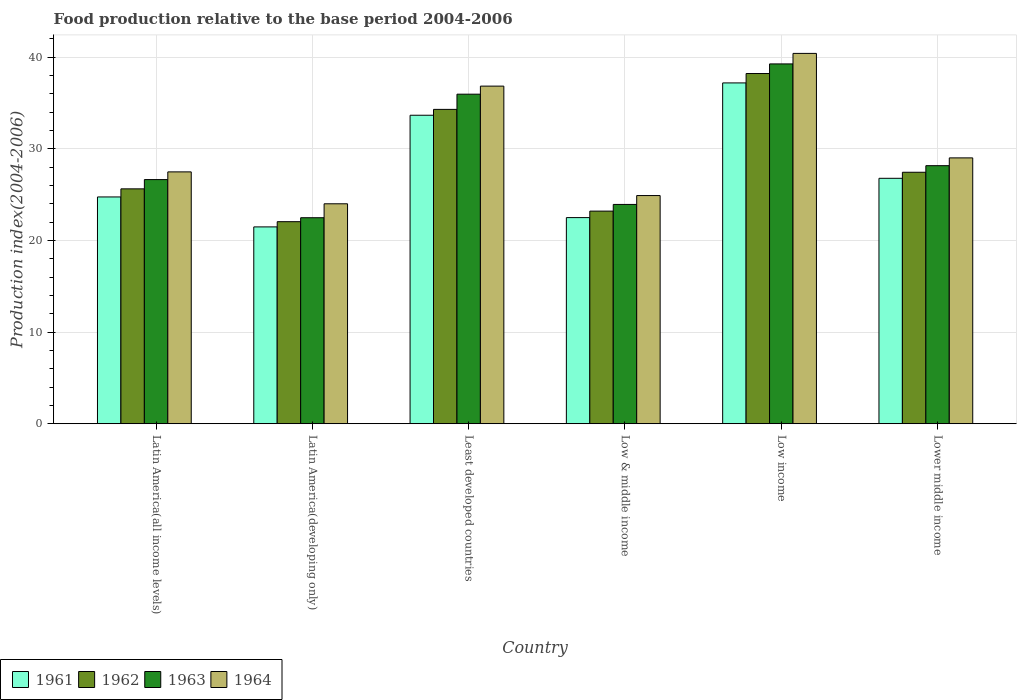How many different coloured bars are there?
Make the answer very short. 4. Are the number of bars per tick equal to the number of legend labels?
Provide a short and direct response. Yes. What is the label of the 6th group of bars from the left?
Give a very brief answer. Lower middle income. In how many cases, is the number of bars for a given country not equal to the number of legend labels?
Your answer should be very brief. 0. What is the food production index in 1963 in Least developed countries?
Your response must be concise. 35.95. Across all countries, what is the maximum food production index in 1964?
Your response must be concise. 40.39. Across all countries, what is the minimum food production index in 1963?
Provide a succinct answer. 22.47. In which country was the food production index in 1964 maximum?
Ensure brevity in your answer.  Low income. In which country was the food production index in 1962 minimum?
Ensure brevity in your answer.  Latin America(developing only). What is the total food production index in 1961 in the graph?
Provide a succinct answer. 166.28. What is the difference between the food production index in 1964 in Latin America(all income levels) and that in Low income?
Your response must be concise. -12.92. What is the difference between the food production index in 1961 in Lower middle income and the food production index in 1963 in Least developed countries?
Offer a terse response. -9.18. What is the average food production index in 1964 per country?
Offer a terse response. 30.43. What is the difference between the food production index of/in 1964 and food production index of/in 1962 in Lower middle income?
Give a very brief answer. 1.57. In how many countries, is the food production index in 1964 greater than 38?
Provide a short and direct response. 1. What is the ratio of the food production index in 1962 in Latin America(developing only) to that in Least developed countries?
Offer a very short reply. 0.64. Is the food production index in 1962 in Least developed countries less than that in Low income?
Provide a short and direct response. Yes. What is the difference between the highest and the second highest food production index in 1964?
Give a very brief answer. 3.57. What is the difference between the highest and the lowest food production index in 1963?
Your answer should be very brief. 16.78. In how many countries, is the food production index in 1963 greater than the average food production index in 1963 taken over all countries?
Make the answer very short. 2. Is it the case that in every country, the sum of the food production index in 1962 and food production index in 1964 is greater than the food production index in 1963?
Offer a very short reply. Yes. Are all the bars in the graph horizontal?
Provide a succinct answer. No. How many countries are there in the graph?
Keep it short and to the point. 6. How many legend labels are there?
Ensure brevity in your answer.  4. How are the legend labels stacked?
Your response must be concise. Horizontal. What is the title of the graph?
Ensure brevity in your answer.  Food production relative to the base period 2004-2006. What is the label or title of the Y-axis?
Provide a short and direct response. Production index(2004-2006). What is the Production index(2004-2006) of 1961 in Latin America(all income levels)?
Your answer should be compact. 24.74. What is the Production index(2004-2006) in 1962 in Latin America(all income levels)?
Offer a very short reply. 25.62. What is the Production index(2004-2006) in 1963 in Latin America(all income levels)?
Ensure brevity in your answer.  26.63. What is the Production index(2004-2006) in 1964 in Latin America(all income levels)?
Your answer should be compact. 27.47. What is the Production index(2004-2006) in 1961 in Latin America(developing only)?
Your answer should be very brief. 21.47. What is the Production index(2004-2006) in 1962 in Latin America(developing only)?
Your response must be concise. 22.04. What is the Production index(2004-2006) of 1963 in Latin America(developing only)?
Your answer should be compact. 22.47. What is the Production index(2004-2006) of 1964 in Latin America(developing only)?
Ensure brevity in your answer.  23.99. What is the Production index(2004-2006) in 1961 in Least developed countries?
Your response must be concise. 33.65. What is the Production index(2004-2006) of 1962 in Least developed countries?
Keep it short and to the point. 34.29. What is the Production index(2004-2006) in 1963 in Least developed countries?
Make the answer very short. 35.95. What is the Production index(2004-2006) of 1964 in Least developed countries?
Give a very brief answer. 36.83. What is the Production index(2004-2006) of 1961 in Low & middle income?
Keep it short and to the point. 22.48. What is the Production index(2004-2006) of 1962 in Low & middle income?
Ensure brevity in your answer.  23.19. What is the Production index(2004-2006) in 1963 in Low & middle income?
Provide a succinct answer. 23.92. What is the Production index(2004-2006) of 1964 in Low & middle income?
Give a very brief answer. 24.89. What is the Production index(2004-2006) in 1961 in Low income?
Ensure brevity in your answer.  37.17. What is the Production index(2004-2006) of 1962 in Low income?
Your answer should be very brief. 38.2. What is the Production index(2004-2006) in 1963 in Low income?
Your answer should be very brief. 39.25. What is the Production index(2004-2006) in 1964 in Low income?
Your answer should be very brief. 40.39. What is the Production index(2004-2006) in 1961 in Lower middle income?
Keep it short and to the point. 26.77. What is the Production index(2004-2006) in 1962 in Lower middle income?
Offer a very short reply. 27.43. What is the Production index(2004-2006) of 1963 in Lower middle income?
Ensure brevity in your answer.  28.15. What is the Production index(2004-2006) of 1964 in Lower middle income?
Your answer should be very brief. 29. Across all countries, what is the maximum Production index(2004-2006) of 1961?
Your answer should be compact. 37.17. Across all countries, what is the maximum Production index(2004-2006) in 1962?
Make the answer very short. 38.2. Across all countries, what is the maximum Production index(2004-2006) in 1963?
Offer a very short reply. 39.25. Across all countries, what is the maximum Production index(2004-2006) in 1964?
Keep it short and to the point. 40.39. Across all countries, what is the minimum Production index(2004-2006) of 1961?
Provide a short and direct response. 21.47. Across all countries, what is the minimum Production index(2004-2006) of 1962?
Keep it short and to the point. 22.04. Across all countries, what is the minimum Production index(2004-2006) in 1963?
Provide a short and direct response. 22.47. Across all countries, what is the minimum Production index(2004-2006) of 1964?
Give a very brief answer. 23.99. What is the total Production index(2004-2006) in 1961 in the graph?
Offer a terse response. 166.28. What is the total Production index(2004-2006) in 1962 in the graph?
Keep it short and to the point. 170.77. What is the total Production index(2004-2006) of 1963 in the graph?
Your answer should be compact. 176.36. What is the total Production index(2004-2006) of 1964 in the graph?
Offer a very short reply. 182.57. What is the difference between the Production index(2004-2006) in 1961 in Latin America(all income levels) and that in Latin America(developing only)?
Give a very brief answer. 3.27. What is the difference between the Production index(2004-2006) in 1962 in Latin America(all income levels) and that in Latin America(developing only)?
Provide a short and direct response. 3.58. What is the difference between the Production index(2004-2006) of 1963 in Latin America(all income levels) and that in Latin America(developing only)?
Keep it short and to the point. 4.16. What is the difference between the Production index(2004-2006) in 1964 in Latin America(all income levels) and that in Latin America(developing only)?
Your response must be concise. 3.48. What is the difference between the Production index(2004-2006) in 1961 in Latin America(all income levels) and that in Least developed countries?
Provide a succinct answer. -8.91. What is the difference between the Production index(2004-2006) in 1962 in Latin America(all income levels) and that in Least developed countries?
Provide a short and direct response. -8.67. What is the difference between the Production index(2004-2006) of 1963 in Latin America(all income levels) and that in Least developed countries?
Ensure brevity in your answer.  -9.32. What is the difference between the Production index(2004-2006) in 1964 in Latin America(all income levels) and that in Least developed countries?
Keep it short and to the point. -9.35. What is the difference between the Production index(2004-2006) of 1961 in Latin America(all income levels) and that in Low & middle income?
Give a very brief answer. 2.25. What is the difference between the Production index(2004-2006) of 1962 in Latin America(all income levels) and that in Low & middle income?
Provide a succinct answer. 2.43. What is the difference between the Production index(2004-2006) in 1963 in Latin America(all income levels) and that in Low & middle income?
Offer a terse response. 2.71. What is the difference between the Production index(2004-2006) in 1964 in Latin America(all income levels) and that in Low & middle income?
Give a very brief answer. 2.58. What is the difference between the Production index(2004-2006) in 1961 in Latin America(all income levels) and that in Low income?
Offer a terse response. -12.44. What is the difference between the Production index(2004-2006) of 1962 in Latin America(all income levels) and that in Low income?
Make the answer very short. -12.58. What is the difference between the Production index(2004-2006) of 1963 in Latin America(all income levels) and that in Low income?
Offer a terse response. -12.62. What is the difference between the Production index(2004-2006) of 1964 in Latin America(all income levels) and that in Low income?
Your answer should be compact. -12.92. What is the difference between the Production index(2004-2006) in 1961 in Latin America(all income levels) and that in Lower middle income?
Your response must be concise. -2.03. What is the difference between the Production index(2004-2006) of 1962 in Latin America(all income levels) and that in Lower middle income?
Offer a very short reply. -1.81. What is the difference between the Production index(2004-2006) of 1963 in Latin America(all income levels) and that in Lower middle income?
Keep it short and to the point. -1.52. What is the difference between the Production index(2004-2006) in 1964 in Latin America(all income levels) and that in Lower middle income?
Make the answer very short. -1.53. What is the difference between the Production index(2004-2006) of 1961 in Latin America(developing only) and that in Least developed countries?
Provide a succinct answer. -12.18. What is the difference between the Production index(2004-2006) in 1962 in Latin America(developing only) and that in Least developed countries?
Your answer should be compact. -12.25. What is the difference between the Production index(2004-2006) of 1963 in Latin America(developing only) and that in Least developed countries?
Ensure brevity in your answer.  -13.47. What is the difference between the Production index(2004-2006) in 1964 in Latin America(developing only) and that in Least developed countries?
Provide a succinct answer. -12.83. What is the difference between the Production index(2004-2006) of 1961 in Latin America(developing only) and that in Low & middle income?
Offer a very short reply. -1.01. What is the difference between the Production index(2004-2006) in 1962 in Latin America(developing only) and that in Low & middle income?
Your response must be concise. -1.15. What is the difference between the Production index(2004-2006) of 1963 in Latin America(developing only) and that in Low & middle income?
Your answer should be very brief. -1.45. What is the difference between the Production index(2004-2006) of 1964 in Latin America(developing only) and that in Low & middle income?
Keep it short and to the point. -0.9. What is the difference between the Production index(2004-2006) in 1961 in Latin America(developing only) and that in Low income?
Provide a succinct answer. -15.71. What is the difference between the Production index(2004-2006) of 1962 in Latin America(developing only) and that in Low income?
Make the answer very short. -16.16. What is the difference between the Production index(2004-2006) of 1963 in Latin America(developing only) and that in Low income?
Your answer should be very brief. -16.78. What is the difference between the Production index(2004-2006) in 1964 in Latin America(developing only) and that in Low income?
Your answer should be compact. -16.4. What is the difference between the Production index(2004-2006) of 1961 in Latin America(developing only) and that in Lower middle income?
Your answer should be very brief. -5.3. What is the difference between the Production index(2004-2006) in 1962 in Latin America(developing only) and that in Lower middle income?
Your answer should be very brief. -5.39. What is the difference between the Production index(2004-2006) in 1963 in Latin America(developing only) and that in Lower middle income?
Ensure brevity in your answer.  -5.68. What is the difference between the Production index(2004-2006) of 1964 in Latin America(developing only) and that in Lower middle income?
Provide a short and direct response. -5.01. What is the difference between the Production index(2004-2006) in 1961 in Least developed countries and that in Low & middle income?
Ensure brevity in your answer.  11.17. What is the difference between the Production index(2004-2006) in 1962 in Least developed countries and that in Low & middle income?
Ensure brevity in your answer.  11.1. What is the difference between the Production index(2004-2006) in 1963 in Least developed countries and that in Low & middle income?
Ensure brevity in your answer.  12.02. What is the difference between the Production index(2004-2006) of 1964 in Least developed countries and that in Low & middle income?
Offer a terse response. 11.94. What is the difference between the Production index(2004-2006) in 1961 in Least developed countries and that in Low income?
Make the answer very short. -3.53. What is the difference between the Production index(2004-2006) in 1962 in Least developed countries and that in Low income?
Ensure brevity in your answer.  -3.91. What is the difference between the Production index(2004-2006) of 1963 in Least developed countries and that in Low income?
Your answer should be very brief. -3.3. What is the difference between the Production index(2004-2006) of 1964 in Least developed countries and that in Low income?
Give a very brief answer. -3.57. What is the difference between the Production index(2004-2006) of 1961 in Least developed countries and that in Lower middle income?
Make the answer very short. 6.88. What is the difference between the Production index(2004-2006) in 1962 in Least developed countries and that in Lower middle income?
Make the answer very short. 6.86. What is the difference between the Production index(2004-2006) of 1963 in Least developed countries and that in Lower middle income?
Your response must be concise. 7.8. What is the difference between the Production index(2004-2006) of 1964 in Least developed countries and that in Lower middle income?
Provide a succinct answer. 7.83. What is the difference between the Production index(2004-2006) of 1961 in Low & middle income and that in Low income?
Your answer should be very brief. -14.69. What is the difference between the Production index(2004-2006) in 1962 in Low & middle income and that in Low income?
Keep it short and to the point. -15.01. What is the difference between the Production index(2004-2006) in 1963 in Low & middle income and that in Low income?
Your answer should be very brief. -15.33. What is the difference between the Production index(2004-2006) of 1964 in Low & middle income and that in Low income?
Offer a terse response. -15.51. What is the difference between the Production index(2004-2006) in 1961 in Low & middle income and that in Lower middle income?
Keep it short and to the point. -4.29. What is the difference between the Production index(2004-2006) in 1962 in Low & middle income and that in Lower middle income?
Give a very brief answer. -4.24. What is the difference between the Production index(2004-2006) of 1963 in Low & middle income and that in Lower middle income?
Your answer should be compact. -4.23. What is the difference between the Production index(2004-2006) in 1964 in Low & middle income and that in Lower middle income?
Give a very brief answer. -4.11. What is the difference between the Production index(2004-2006) in 1961 in Low income and that in Lower middle income?
Give a very brief answer. 10.4. What is the difference between the Production index(2004-2006) of 1962 in Low income and that in Lower middle income?
Keep it short and to the point. 10.77. What is the difference between the Production index(2004-2006) of 1963 in Low income and that in Lower middle income?
Offer a very short reply. 11.1. What is the difference between the Production index(2004-2006) in 1964 in Low income and that in Lower middle income?
Keep it short and to the point. 11.4. What is the difference between the Production index(2004-2006) of 1961 in Latin America(all income levels) and the Production index(2004-2006) of 1962 in Latin America(developing only)?
Ensure brevity in your answer.  2.7. What is the difference between the Production index(2004-2006) of 1961 in Latin America(all income levels) and the Production index(2004-2006) of 1963 in Latin America(developing only)?
Ensure brevity in your answer.  2.27. What is the difference between the Production index(2004-2006) in 1961 in Latin America(all income levels) and the Production index(2004-2006) in 1964 in Latin America(developing only)?
Give a very brief answer. 0.75. What is the difference between the Production index(2004-2006) of 1962 in Latin America(all income levels) and the Production index(2004-2006) of 1963 in Latin America(developing only)?
Ensure brevity in your answer.  3.15. What is the difference between the Production index(2004-2006) in 1962 in Latin America(all income levels) and the Production index(2004-2006) in 1964 in Latin America(developing only)?
Offer a very short reply. 1.63. What is the difference between the Production index(2004-2006) of 1963 in Latin America(all income levels) and the Production index(2004-2006) of 1964 in Latin America(developing only)?
Your answer should be very brief. 2.64. What is the difference between the Production index(2004-2006) of 1961 in Latin America(all income levels) and the Production index(2004-2006) of 1962 in Least developed countries?
Your answer should be very brief. -9.55. What is the difference between the Production index(2004-2006) in 1961 in Latin America(all income levels) and the Production index(2004-2006) in 1963 in Least developed countries?
Give a very brief answer. -11.21. What is the difference between the Production index(2004-2006) of 1961 in Latin America(all income levels) and the Production index(2004-2006) of 1964 in Least developed countries?
Provide a succinct answer. -12.09. What is the difference between the Production index(2004-2006) in 1962 in Latin America(all income levels) and the Production index(2004-2006) in 1963 in Least developed countries?
Ensure brevity in your answer.  -10.33. What is the difference between the Production index(2004-2006) in 1962 in Latin America(all income levels) and the Production index(2004-2006) in 1964 in Least developed countries?
Provide a succinct answer. -11.21. What is the difference between the Production index(2004-2006) in 1963 in Latin America(all income levels) and the Production index(2004-2006) in 1964 in Least developed countries?
Make the answer very short. -10.2. What is the difference between the Production index(2004-2006) of 1961 in Latin America(all income levels) and the Production index(2004-2006) of 1962 in Low & middle income?
Your answer should be very brief. 1.54. What is the difference between the Production index(2004-2006) in 1961 in Latin America(all income levels) and the Production index(2004-2006) in 1963 in Low & middle income?
Make the answer very short. 0.82. What is the difference between the Production index(2004-2006) of 1961 in Latin America(all income levels) and the Production index(2004-2006) of 1964 in Low & middle income?
Make the answer very short. -0.15. What is the difference between the Production index(2004-2006) of 1962 in Latin America(all income levels) and the Production index(2004-2006) of 1963 in Low & middle income?
Your answer should be very brief. 1.7. What is the difference between the Production index(2004-2006) in 1962 in Latin America(all income levels) and the Production index(2004-2006) in 1964 in Low & middle income?
Keep it short and to the point. 0.73. What is the difference between the Production index(2004-2006) in 1963 in Latin America(all income levels) and the Production index(2004-2006) in 1964 in Low & middle income?
Ensure brevity in your answer.  1.74. What is the difference between the Production index(2004-2006) in 1961 in Latin America(all income levels) and the Production index(2004-2006) in 1962 in Low income?
Make the answer very short. -13.46. What is the difference between the Production index(2004-2006) of 1961 in Latin America(all income levels) and the Production index(2004-2006) of 1963 in Low income?
Provide a succinct answer. -14.51. What is the difference between the Production index(2004-2006) of 1961 in Latin America(all income levels) and the Production index(2004-2006) of 1964 in Low income?
Your response must be concise. -15.66. What is the difference between the Production index(2004-2006) in 1962 in Latin America(all income levels) and the Production index(2004-2006) in 1963 in Low income?
Provide a short and direct response. -13.63. What is the difference between the Production index(2004-2006) in 1962 in Latin America(all income levels) and the Production index(2004-2006) in 1964 in Low income?
Make the answer very short. -14.77. What is the difference between the Production index(2004-2006) of 1963 in Latin America(all income levels) and the Production index(2004-2006) of 1964 in Low income?
Ensure brevity in your answer.  -13.76. What is the difference between the Production index(2004-2006) of 1961 in Latin America(all income levels) and the Production index(2004-2006) of 1962 in Lower middle income?
Your answer should be compact. -2.69. What is the difference between the Production index(2004-2006) of 1961 in Latin America(all income levels) and the Production index(2004-2006) of 1963 in Lower middle income?
Offer a very short reply. -3.41. What is the difference between the Production index(2004-2006) of 1961 in Latin America(all income levels) and the Production index(2004-2006) of 1964 in Lower middle income?
Offer a very short reply. -4.26. What is the difference between the Production index(2004-2006) in 1962 in Latin America(all income levels) and the Production index(2004-2006) in 1963 in Lower middle income?
Your answer should be very brief. -2.53. What is the difference between the Production index(2004-2006) in 1962 in Latin America(all income levels) and the Production index(2004-2006) in 1964 in Lower middle income?
Keep it short and to the point. -3.38. What is the difference between the Production index(2004-2006) of 1963 in Latin America(all income levels) and the Production index(2004-2006) of 1964 in Lower middle income?
Your answer should be very brief. -2.37. What is the difference between the Production index(2004-2006) of 1961 in Latin America(developing only) and the Production index(2004-2006) of 1962 in Least developed countries?
Your response must be concise. -12.82. What is the difference between the Production index(2004-2006) in 1961 in Latin America(developing only) and the Production index(2004-2006) in 1963 in Least developed countries?
Your answer should be very brief. -14.48. What is the difference between the Production index(2004-2006) of 1961 in Latin America(developing only) and the Production index(2004-2006) of 1964 in Least developed countries?
Offer a very short reply. -15.36. What is the difference between the Production index(2004-2006) in 1962 in Latin America(developing only) and the Production index(2004-2006) in 1963 in Least developed countries?
Provide a succinct answer. -13.91. What is the difference between the Production index(2004-2006) in 1962 in Latin America(developing only) and the Production index(2004-2006) in 1964 in Least developed countries?
Offer a very short reply. -14.79. What is the difference between the Production index(2004-2006) in 1963 in Latin America(developing only) and the Production index(2004-2006) in 1964 in Least developed countries?
Offer a terse response. -14.35. What is the difference between the Production index(2004-2006) in 1961 in Latin America(developing only) and the Production index(2004-2006) in 1962 in Low & middle income?
Provide a short and direct response. -1.72. What is the difference between the Production index(2004-2006) of 1961 in Latin America(developing only) and the Production index(2004-2006) of 1963 in Low & middle income?
Provide a short and direct response. -2.45. What is the difference between the Production index(2004-2006) of 1961 in Latin America(developing only) and the Production index(2004-2006) of 1964 in Low & middle income?
Your response must be concise. -3.42. What is the difference between the Production index(2004-2006) in 1962 in Latin America(developing only) and the Production index(2004-2006) in 1963 in Low & middle income?
Provide a succinct answer. -1.88. What is the difference between the Production index(2004-2006) of 1962 in Latin America(developing only) and the Production index(2004-2006) of 1964 in Low & middle income?
Offer a terse response. -2.85. What is the difference between the Production index(2004-2006) of 1963 in Latin America(developing only) and the Production index(2004-2006) of 1964 in Low & middle income?
Your answer should be very brief. -2.42. What is the difference between the Production index(2004-2006) in 1961 in Latin America(developing only) and the Production index(2004-2006) in 1962 in Low income?
Offer a terse response. -16.73. What is the difference between the Production index(2004-2006) of 1961 in Latin America(developing only) and the Production index(2004-2006) of 1963 in Low income?
Give a very brief answer. -17.78. What is the difference between the Production index(2004-2006) of 1961 in Latin America(developing only) and the Production index(2004-2006) of 1964 in Low income?
Your answer should be compact. -18.93. What is the difference between the Production index(2004-2006) in 1962 in Latin America(developing only) and the Production index(2004-2006) in 1963 in Low income?
Keep it short and to the point. -17.21. What is the difference between the Production index(2004-2006) of 1962 in Latin America(developing only) and the Production index(2004-2006) of 1964 in Low income?
Your response must be concise. -18.35. What is the difference between the Production index(2004-2006) in 1963 in Latin America(developing only) and the Production index(2004-2006) in 1964 in Low income?
Provide a short and direct response. -17.92. What is the difference between the Production index(2004-2006) of 1961 in Latin America(developing only) and the Production index(2004-2006) of 1962 in Lower middle income?
Your response must be concise. -5.96. What is the difference between the Production index(2004-2006) of 1961 in Latin America(developing only) and the Production index(2004-2006) of 1963 in Lower middle income?
Provide a short and direct response. -6.68. What is the difference between the Production index(2004-2006) in 1961 in Latin America(developing only) and the Production index(2004-2006) in 1964 in Lower middle income?
Make the answer very short. -7.53. What is the difference between the Production index(2004-2006) in 1962 in Latin America(developing only) and the Production index(2004-2006) in 1963 in Lower middle income?
Provide a short and direct response. -6.11. What is the difference between the Production index(2004-2006) of 1962 in Latin America(developing only) and the Production index(2004-2006) of 1964 in Lower middle income?
Provide a succinct answer. -6.96. What is the difference between the Production index(2004-2006) in 1963 in Latin America(developing only) and the Production index(2004-2006) in 1964 in Lower middle income?
Your answer should be very brief. -6.53. What is the difference between the Production index(2004-2006) of 1961 in Least developed countries and the Production index(2004-2006) of 1962 in Low & middle income?
Provide a short and direct response. 10.46. What is the difference between the Production index(2004-2006) in 1961 in Least developed countries and the Production index(2004-2006) in 1963 in Low & middle income?
Keep it short and to the point. 9.73. What is the difference between the Production index(2004-2006) in 1961 in Least developed countries and the Production index(2004-2006) in 1964 in Low & middle income?
Provide a succinct answer. 8.76. What is the difference between the Production index(2004-2006) of 1962 in Least developed countries and the Production index(2004-2006) of 1963 in Low & middle income?
Your answer should be compact. 10.37. What is the difference between the Production index(2004-2006) of 1962 in Least developed countries and the Production index(2004-2006) of 1964 in Low & middle income?
Make the answer very short. 9.4. What is the difference between the Production index(2004-2006) of 1963 in Least developed countries and the Production index(2004-2006) of 1964 in Low & middle income?
Your answer should be compact. 11.06. What is the difference between the Production index(2004-2006) of 1961 in Least developed countries and the Production index(2004-2006) of 1962 in Low income?
Ensure brevity in your answer.  -4.55. What is the difference between the Production index(2004-2006) in 1961 in Least developed countries and the Production index(2004-2006) in 1963 in Low income?
Provide a short and direct response. -5.6. What is the difference between the Production index(2004-2006) in 1961 in Least developed countries and the Production index(2004-2006) in 1964 in Low income?
Make the answer very short. -6.75. What is the difference between the Production index(2004-2006) in 1962 in Least developed countries and the Production index(2004-2006) in 1963 in Low income?
Your answer should be very brief. -4.96. What is the difference between the Production index(2004-2006) in 1962 in Least developed countries and the Production index(2004-2006) in 1964 in Low income?
Make the answer very short. -6.11. What is the difference between the Production index(2004-2006) in 1963 in Least developed countries and the Production index(2004-2006) in 1964 in Low income?
Keep it short and to the point. -4.45. What is the difference between the Production index(2004-2006) in 1961 in Least developed countries and the Production index(2004-2006) in 1962 in Lower middle income?
Keep it short and to the point. 6.22. What is the difference between the Production index(2004-2006) of 1961 in Least developed countries and the Production index(2004-2006) of 1963 in Lower middle income?
Offer a terse response. 5.5. What is the difference between the Production index(2004-2006) in 1961 in Least developed countries and the Production index(2004-2006) in 1964 in Lower middle income?
Provide a short and direct response. 4.65. What is the difference between the Production index(2004-2006) of 1962 in Least developed countries and the Production index(2004-2006) of 1963 in Lower middle income?
Your answer should be compact. 6.14. What is the difference between the Production index(2004-2006) of 1962 in Least developed countries and the Production index(2004-2006) of 1964 in Lower middle income?
Keep it short and to the point. 5.29. What is the difference between the Production index(2004-2006) of 1963 in Least developed countries and the Production index(2004-2006) of 1964 in Lower middle income?
Ensure brevity in your answer.  6.95. What is the difference between the Production index(2004-2006) of 1961 in Low & middle income and the Production index(2004-2006) of 1962 in Low income?
Offer a very short reply. -15.72. What is the difference between the Production index(2004-2006) in 1961 in Low & middle income and the Production index(2004-2006) in 1963 in Low income?
Offer a terse response. -16.76. What is the difference between the Production index(2004-2006) in 1961 in Low & middle income and the Production index(2004-2006) in 1964 in Low income?
Keep it short and to the point. -17.91. What is the difference between the Production index(2004-2006) in 1962 in Low & middle income and the Production index(2004-2006) in 1963 in Low income?
Give a very brief answer. -16.06. What is the difference between the Production index(2004-2006) of 1962 in Low & middle income and the Production index(2004-2006) of 1964 in Low income?
Give a very brief answer. -17.2. What is the difference between the Production index(2004-2006) of 1963 in Low & middle income and the Production index(2004-2006) of 1964 in Low income?
Your response must be concise. -16.47. What is the difference between the Production index(2004-2006) of 1961 in Low & middle income and the Production index(2004-2006) of 1962 in Lower middle income?
Offer a very short reply. -4.95. What is the difference between the Production index(2004-2006) of 1961 in Low & middle income and the Production index(2004-2006) of 1963 in Lower middle income?
Ensure brevity in your answer.  -5.66. What is the difference between the Production index(2004-2006) in 1961 in Low & middle income and the Production index(2004-2006) in 1964 in Lower middle income?
Your answer should be very brief. -6.51. What is the difference between the Production index(2004-2006) of 1962 in Low & middle income and the Production index(2004-2006) of 1963 in Lower middle income?
Offer a terse response. -4.96. What is the difference between the Production index(2004-2006) in 1962 in Low & middle income and the Production index(2004-2006) in 1964 in Lower middle income?
Give a very brief answer. -5.81. What is the difference between the Production index(2004-2006) in 1963 in Low & middle income and the Production index(2004-2006) in 1964 in Lower middle income?
Provide a succinct answer. -5.08. What is the difference between the Production index(2004-2006) of 1961 in Low income and the Production index(2004-2006) of 1962 in Lower middle income?
Provide a succinct answer. 9.74. What is the difference between the Production index(2004-2006) in 1961 in Low income and the Production index(2004-2006) in 1963 in Lower middle income?
Keep it short and to the point. 9.03. What is the difference between the Production index(2004-2006) in 1961 in Low income and the Production index(2004-2006) in 1964 in Lower middle income?
Offer a very short reply. 8.18. What is the difference between the Production index(2004-2006) of 1962 in Low income and the Production index(2004-2006) of 1963 in Lower middle income?
Provide a short and direct response. 10.05. What is the difference between the Production index(2004-2006) of 1962 in Low income and the Production index(2004-2006) of 1964 in Lower middle income?
Your response must be concise. 9.2. What is the difference between the Production index(2004-2006) in 1963 in Low income and the Production index(2004-2006) in 1964 in Lower middle income?
Provide a succinct answer. 10.25. What is the average Production index(2004-2006) of 1961 per country?
Offer a terse response. 27.71. What is the average Production index(2004-2006) of 1962 per country?
Provide a succinct answer. 28.46. What is the average Production index(2004-2006) in 1963 per country?
Your answer should be very brief. 29.39. What is the average Production index(2004-2006) in 1964 per country?
Make the answer very short. 30.43. What is the difference between the Production index(2004-2006) of 1961 and Production index(2004-2006) of 1962 in Latin America(all income levels)?
Provide a short and direct response. -0.88. What is the difference between the Production index(2004-2006) in 1961 and Production index(2004-2006) in 1963 in Latin America(all income levels)?
Offer a very short reply. -1.89. What is the difference between the Production index(2004-2006) of 1961 and Production index(2004-2006) of 1964 in Latin America(all income levels)?
Your answer should be compact. -2.74. What is the difference between the Production index(2004-2006) of 1962 and Production index(2004-2006) of 1963 in Latin America(all income levels)?
Keep it short and to the point. -1.01. What is the difference between the Production index(2004-2006) of 1962 and Production index(2004-2006) of 1964 in Latin America(all income levels)?
Provide a succinct answer. -1.85. What is the difference between the Production index(2004-2006) in 1963 and Production index(2004-2006) in 1964 in Latin America(all income levels)?
Make the answer very short. -0.84. What is the difference between the Production index(2004-2006) of 1961 and Production index(2004-2006) of 1962 in Latin America(developing only)?
Give a very brief answer. -0.57. What is the difference between the Production index(2004-2006) of 1961 and Production index(2004-2006) of 1963 in Latin America(developing only)?
Offer a terse response. -1. What is the difference between the Production index(2004-2006) of 1961 and Production index(2004-2006) of 1964 in Latin America(developing only)?
Your answer should be compact. -2.52. What is the difference between the Production index(2004-2006) of 1962 and Production index(2004-2006) of 1963 in Latin America(developing only)?
Offer a very short reply. -0.43. What is the difference between the Production index(2004-2006) of 1962 and Production index(2004-2006) of 1964 in Latin America(developing only)?
Offer a terse response. -1.95. What is the difference between the Production index(2004-2006) of 1963 and Production index(2004-2006) of 1964 in Latin America(developing only)?
Offer a terse response. -1.52. What is the difference between the Production index(2004-2006) in 1961 and Production index(2004-2006) in 1962 in Least developed countries?
Offer a terse response. -0.64. What is the difference between the Production index(2004-2006) of 1961 and Production index(2004-2006) of 1963 in Least developed countries?
Your answer should be very brief. -2.3. What is the difference between the Production index(2004-2006) in 1961 and Production index(2004-2006) in 1964 in Least developed countries?
Provide a short and direct response. -3.18. What is the difference between the Production index(2004-2006) in 1962 and Production index(2004-2006) in 1963 in Least developed countries?
Your answer should be very brief. -1.66. What is the difference between the Production index(2004-2006) in 1962 and Production index(2004-2006) in 1964 in Least developed countries?
Offer a terse response. -2.54. What is the difference between the Production index(2004-2006) in 1963 and Production index(2004-2006) in 1964 in Least developed countries?
Offer a very short reply. -0.88. What is the difference between the Production index(2004-2006) of 1961 and Production index(2004-2006) of 1962 in Low & middle income?
Your answer should be compact. -0.71. What is the difference between the Production index(2004-2006) of 1961 and Production index(2004-2006) of 1963 in Low & middle income?
Offer a very short reply. -1.44. What is the difference between the Production index(2004-2006) of 1961 and Production index(2004-2006) of 1964 in Low & middle income?
Make the answer very short. -2.4. What is the difference between the Production index(2004-2006) in 1962 and Production index(2004-2006) in 1963 in Low & middle income?
Offer a very short reply. -0.73. What is the difference between the Production index(2004-2006) in 1962 and Production index(2004-2006) in 1964 in Low & middle income?
Provide a short and direct response. -1.7. What is the difference between the Production index(2004-2006) of 1963 and Production index(2004-2006) of 1964 in Low & middle income?
Keep it short and to the point. -0.97. What is the difference between the Production index(2004-2006) in 1961 and Production index(2004-2006) in 1962 in Low income?
Your response must be concise. -1.02. What is the difference between the Production index(2004-2006) of 1961 and Production index(2004-2006) of 1963 in Low income?
Your response must be concise. -2.07. What is the difference between the Production index(2004-2006) of 1961 and Production index(2004-2006) of 1964 in Low income?
Offer a very short reply. -3.22. What is the difference between the Production index(2004-2006) of 1962 and Production index(2004-2006) of 1963 in Low income?
Provide a short and direct response. -1.05. What is the difference between the Production index(2004-2006) in 1962 and Production index(2004-2006) in 1964 in Low income?
Ensure brevity in your answer.  -2.2. What is the difference between the Production index(2004-2006) in 1963 and Production index(2004-2006) in 1964 in Low income?
Keep it short and to the point. -1.15. What is the difference between the Production index(2004-2006) of 1961 and Production index(2004-2006) of 1962 in Lower middle income?
Keep it short and to the point. -0.66. What is the difference between the Production index(2004-2006) in 1961 and Production index(2004-2006) in 1963 in Lower middle income?
Provide a succinct answer. -1.38. What is the difference between the Production index(2004-2006) in 1961 and Production index(2004-2006) in 1964 in Lower middle income?
Make the answer very short. -2.23. What is the difference between the Production index(2004-2006) in 1962 and Production index(2004-2006) in 1963 in Lower middle income?
Keep it short and to the point. -0.72. What is the difference between the Production index(2004-2006) of 1962 and Production index(2004-2006) of 1964 in Lower middle income?
Provide a succinct answer. -1.57. What is the difference between the Production index(2004-2006) in 1963 and Production index(2004-2006) in 1964 in Lower middle income?
Make the answer very short. -0.85. What is the ratio of the Production index(2004-2006) in 1961 in Latin America(all income levels) to that in Latin America(developing only)?
Offer a terse response. 1.15. What is the ratio of the Production index(2004-2006) of 1962 in Latin America(all income levels) to that in Latin America(developing only)?
Ensure brevity in your answer.  1.16. What is the ratio of the Production index(2004-2006) in 1963 in Latin America(all income levels) to that in Latin America(developing only)?
Make the answer very short. 1.19. What is the ratio of the Production index(2004-2006) in 1964 in Latin America(all income levels) to that in Latin America(developing only)?
Ensure brevity in your answer.  1.15. What is the ratio of the Production index(2004-2006) in 1961 in Latin America(all income levels) to that in Least developed countries?
Offer a terse response. 0.74. What is the ratio of the Production index(2004-2006) of 1962 in Latin America(all income levels) to that in Least developed countries?
Your answer should be compact. 0.75. What is the ratio of the Production index(2004-2006) in 1963 in Latin America(all income levels) to that in Least developed countries?
Provide a succinct answer. 0.74. What is the ratio of the Production index(2004-2006) of 1964 in Latin America(all income levels) to that in Least developed countries?
Keep it short and to the point. 0.75. What is the ratio of the Production index(2004-2006) in 1961 in Latin America(all income levels) to that in Low & middle income?
Offer a terse response. 1.1. What is the ratio of the Production index(2004-2006) of 1962 in Latin America(all income levels) to that in Low & middle income?
Offer a terse response. 1.1. What is the ratio of the Production index(2004-2006) of 1963 in Latin America(all income levels) to that in Low & middle income?
Offer a terse response. 1.11. What is the ratio of the Production index(2004-2006) in 1964 in Latin America(all income levels) to that in Low & middle income?
Keep it short and to the point. 1.1. What is the ratio of the Production index(2004-2006) of 1961 in Latin America(all income levels) to that in Low income?
Your answer should be very brief. 0.67. What is the ratio of the Production index(2004-2006) of 1962 in Latin America(all income levels) to that in Low income?
Offer a very short reply. 0.67. What is the ratio of the Production index(2004-2006) of 1963 in Latin America(all income levels) to that in Low income?
Keep it short and to the point. 0.68. What is the ratio of the Production index(2004-2006) of 1964 in Latin America(all income levels) to that in Low income?
Keep it short and to the point. 0.68. What is the ratio of the Production index(2004-2006) of 1961 in Latin America(all income levels) to that in Lower middle income?
Provide a short and direct response. 0.92. What is the ratio of the Production index(2004-2006) of 1962 in Latin America(all income levels) to that in Lower middle income?
Offer a very short reply. 0.93. What is the ratio of the Production index(2004-2006) of 1963 in Latin America(all income levels) to that in Lower middle income?
Provide a succinct answer. 0.95. What is the ratio of the Production index(2004-2006) of 1961 in Latin America(developing only) to that in Least developed countries?
Provide a succinct answer. 0.64. What is the ratio of the Production index(2004-2006) in 1962 in Latin America(developing only) to that in Least developed countries?
Make the answer very short. 0.64. What is the ratio of the Production index(2004-2006) of 1963 in Latin America(developing only) to that in Least developed countries?
Provide a short and direct response. 0.63. What is the ratio of the Production index(2004-2006) in 1964 in Latin America(developing only) to that in Least developed countries?
Provide a succinct answer. 0.65. What is the ratio of the Production index(2004-2006) of 1961 in Latin America(developing only) to that in Low & middle income?
Make the answer very short. 0.95. What is the ratio of the Production index(2004-2006) of 1962 in Latin America(developing only) to that in Low & middle income?
Make the answer very short. 0.95. What is the ratio of the Production index(2004-2006) of 1963 in Latin America(developing only) to that in Low & middle income?
Provide a succinct answer. 0.94. What is the ratio of the Production index(2004-2006) in 1964 in Latin America(developing only) to that in Low & middle income?
Offer a terse response. 0.96. What is the ratio of the Production index(2004-2006) of 1961 in Latin America(developing only) to that in Low income?
Provide a short and direct response. 0.58. What is the ratio of the Production index(2004-2006) of 1962 in Latin America(developing only) to that in Low income?
Provide a short and direct response. 0.58. What is the ratio of the Production index(2004-2006) in 1963 in Latin America(developing only) to that in Low income?
Your answer should be very brief. 0.57. What is the ratio of the Production index(2004-2006) in 1964 in Latin America(developing only) to that in Low income?
Your answer should be compact. 0.59. What is the ratio of the Production index(2004-2006) of 1961 in Latin America(developing only) to that in Lower middle income?
Keep it short and to the point. 0.8. What is the ratio of the Production index(2004-2006) in 1962 in Latin America(developing only) to that in Lower middle income?
Ensure brevity in your answer.  0.8. What is the ratio of the Production index(2004-2006) of 1963 in Latin America(developing only) to that in Lower middle income?
Provide a short and direct response. 0.8. What is the ratio of the Production index(2004-2006) in 1964 in Latin America(developing only) to that in Lower middle income?
Make the answer very short. 0.83. What is the ratio of the Production index(2004-2006) of 1961 in Least developed countries to that in Low & middle income?
Provide a short and direct response. 1.5. What is the ratio of the Production index(2004-2006) in 1962 in Least developed countries to that in Low & middle income?
Your answer should be very brief. 1.48. What is the ratio of the Production index(2004-2006) in 1963 in Least developed countries to that in Low & middle income?
Make the answer very short. 1.5. What is the ratio of the Production index(2004-2006) of 1964 in Least developed countries to that in Low & middle income?
Your answer should be compact. 1.48. What is the ratio of the Production index(2004-2006) of 1961 in Least developed countries to that in Low income?
Give a very brief answer. 0.91. What is the ratio of the Production index(2004-2006) in 1962 in Least developed countries to that in Low income?
Your answer should be very brief. 0.9. What is the ratio of the Production index(2004-2006) of 1963 in Least developed countries to that in Low income?
Keep it short and to the point. 0.92. What is the ratio of the Production index(2004-2006) of 1964 in Least developed countries to that in Low income?
Make the answer very short. 0.91. What is the ratio of the Production index(2004-2006) in 1961 in Least developed countries to that in Lower middle income?
Provide a short and direct response. 1.26. What is the ratio of the Production index(2004-2006) in 1963 in Least developed countries to that in Lower middle income?
Give a very brief answer. 1.28. What is the ratio of the Production index(2004-2006) in 1964 in Least developed countries to that in Lower middle income?
Ensure brevity in your answer.  1.27. What is the ratio of the Production index(2004-2006) of 1961 in Low & middle income to that in Low income?
Your answer should be compact. 0.6. What is the ratio of the Production index(2004-2006) in 1962 in Low & middle income to that in Low income?
Keep it short and to the point. 0.61. What is the ratio of the Production index(2004-2006) of 1963 in Low & middle income to that in Low income?
Your answer should be very brief. 0.61. What is the ratio of the Production index(2004-2006) of 1964 in Low & middle income to that in Low income?
Your response must be concise. 0.62. What is the ratio of the Production index(2004-2006) of 1961 in Low & middle income to that in Lower middle income?
Keep it short and to the point. 0.84. What is the ratio of the Production index(2004-2006) of 1962 in Low & middle income to that in Lower middle income?
Keep it short and to the point. 0.85. What is the ratio of the Production index(2004-2006) in 1963 in Low & middle income to that in Lower middle income?
Provide a short and direct response. 0.85. What is the ratio of the Production index(2004-2006) of 1964 in Low & middle income to that in Lower middle income?
Make the answer very short. 0.86. What is the ratio of the Production index(2004-2006) of 1961 in Low income to that in Lower middle income?
Keep it short and to the point. 1.39. What is the ratio of the Production index(2004-2006) in 1962 in Low income to that in Lower middle income?
Your answer should be very brief. 1.39. What is the ratio of the Production index(2004-2006) in 1963 in Low income to that in Lower middle income?
Provide a succinct answer. 1.39. What is the ratio of the Production index(2004-2006) of 1964 in Low income to that in Lower middle income?
Ensure brevity in your answer.  1.39. What is the difference between the highest and the second highest Production index(2004-2006) in 1961?
Give a very brief answer. 3.53. What is the difference between the highest and the second highest Production index(2004-2006) in 1962?
Ensure brevity in your answer.  3.91. What is the difference between the highest and the second highest Production index(2004-2006) of 1963?
Your answer should be very brief. 3.3. What is the difference between the highest and the second highest Production index(2004-2006) in 1964?
Make the answer very short. 3.57. What is the difference between the highest and the lowest Production index(2004-2006) of 1961?
Keep it short and to the point. 15.71. What is the difference between the highest and the lowest Production index(2004-2006) of 1962?
Make the answer very short. 16.16. What is the difference between the highest and the lowest Production index(2004-2006) of 1963?
Provide a short and direct response. 16.78. What is the difference between the highest and the lowest Production index(2004-2006) of 1964?
Provide a short and direct response. 16.4. 